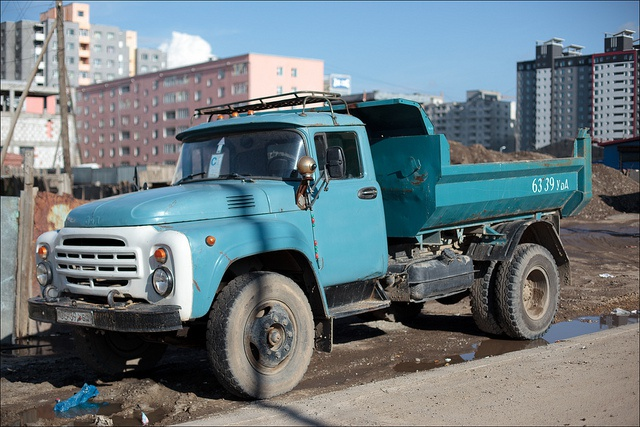Describe the objects in this image and their specific colors. I can see a truck in black, gray, lightblue, and teal tones in this image. 